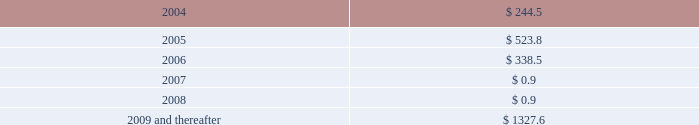Notes to consolidated financial statements ( dollars in millions , except per share amounts ) long-term debt maturing over the next five years and thereafter is as follows: .
On march 7 , 2003 , standard & poor's ratings services downgraded the company's senior secured credit rating to bb+ with negative outlook from bbb- .
On may 14 , 2003 , fitch ratings downgraded the company's senior unsecured credit rating to bb+ with negative outlook from bbb- .
On may 9 , 2003 , moody's investor services , inc .
( "moody's" ) placed the company's senior unsecured and subordinated credit ratings on review for possible downgrade from baa3 and ba1 , respectively .
As of march 12 , 2004 , the company's credit ratings continued to be on review for a possible downgrade .
Since july 2001 , the company has not repurchased its common stock in the open market .
In october 2003 , the company received a federal tax refund of approximately $ 90 as a result of its carryback of its 2002 loss for us federal income tax purposes and certain capital losses , to earlier periods .
Through december 2002 , the company had paid cash dividends quarterly with the most recent quarterly dividend paid in december 2002 at a rate of $ 0.095 per share .
On a quarterly basis , the company's board of directors makes determinations regarding the payment of dividends .
As previously discussed , the company's ability to declare or pay dividends is currently restricted by the terms of its revolving credit facilities .
The company did not declare or pay any dividends in 2003 .
However , in 2004 , the company expects to pay any dividends accruing on the series a mandatory convertible preferred stock in cash , which is expressly permitted by the revolving credit facilities .
See note 14 for discussion of fair market value of the company's long-term debt .
Note 9 : equity offering on december 16 , 2003 , the company sold 25.8 million shares of common stock and issued 7.5 million shares of 3- year series a mandatory convertible preferred stock ( the "preferred stock" ) .
The total net proceeds received from the concurrent offerings was approximately $ 693 .
The preferred stock carries a dividend yield of 5.375% ( 5.375 % ) .
On maturity , each share of the preferred stock will convert , subject to adjustment , to between 3.0358 and 3.7037 shares of common stock , depending on the then-current market price of the company's common stock , representing a conversion premium of approximately 22% ( 22 % ) over the stock offering price of $ 13.50 per share .
Under certain circumstances , the preferred stock may be converted prior to maturity at the option of the holders or the company .
The common and preferred stock were issued under the company's existing shelf registration statement .
In january 2004 , the company used approximately $ 246 of the net proceeds from the offerings to redeem the 1.80% ( 1.80 % ) convertible subordinated notes due 2004 .
The remaining proceeds will be used for general corporate purposes and to further strengthen the company's balance sheet and financial condition .
The company will pay annual dividends on each share of the series a mandatory convertible preferred stock in the amount of $ 2.6875 .
Dividends will be cumulative from the date of issuance and will be payable on each payment date to the extent that dividends are not restricted under the company's credit facilities and assets are legally available to pay dividends .
The first dividend payment , which was declared on february 24 , 2004 , will be made on march 15 , 2004. .
What is the total long-term debt reported in the balance sheet as of december 2003? 
Computations: (((((244.5 + 523.8) + 338.5) + 0.9) + 0.9) + 1327.6)
Answer: 2436.2. 